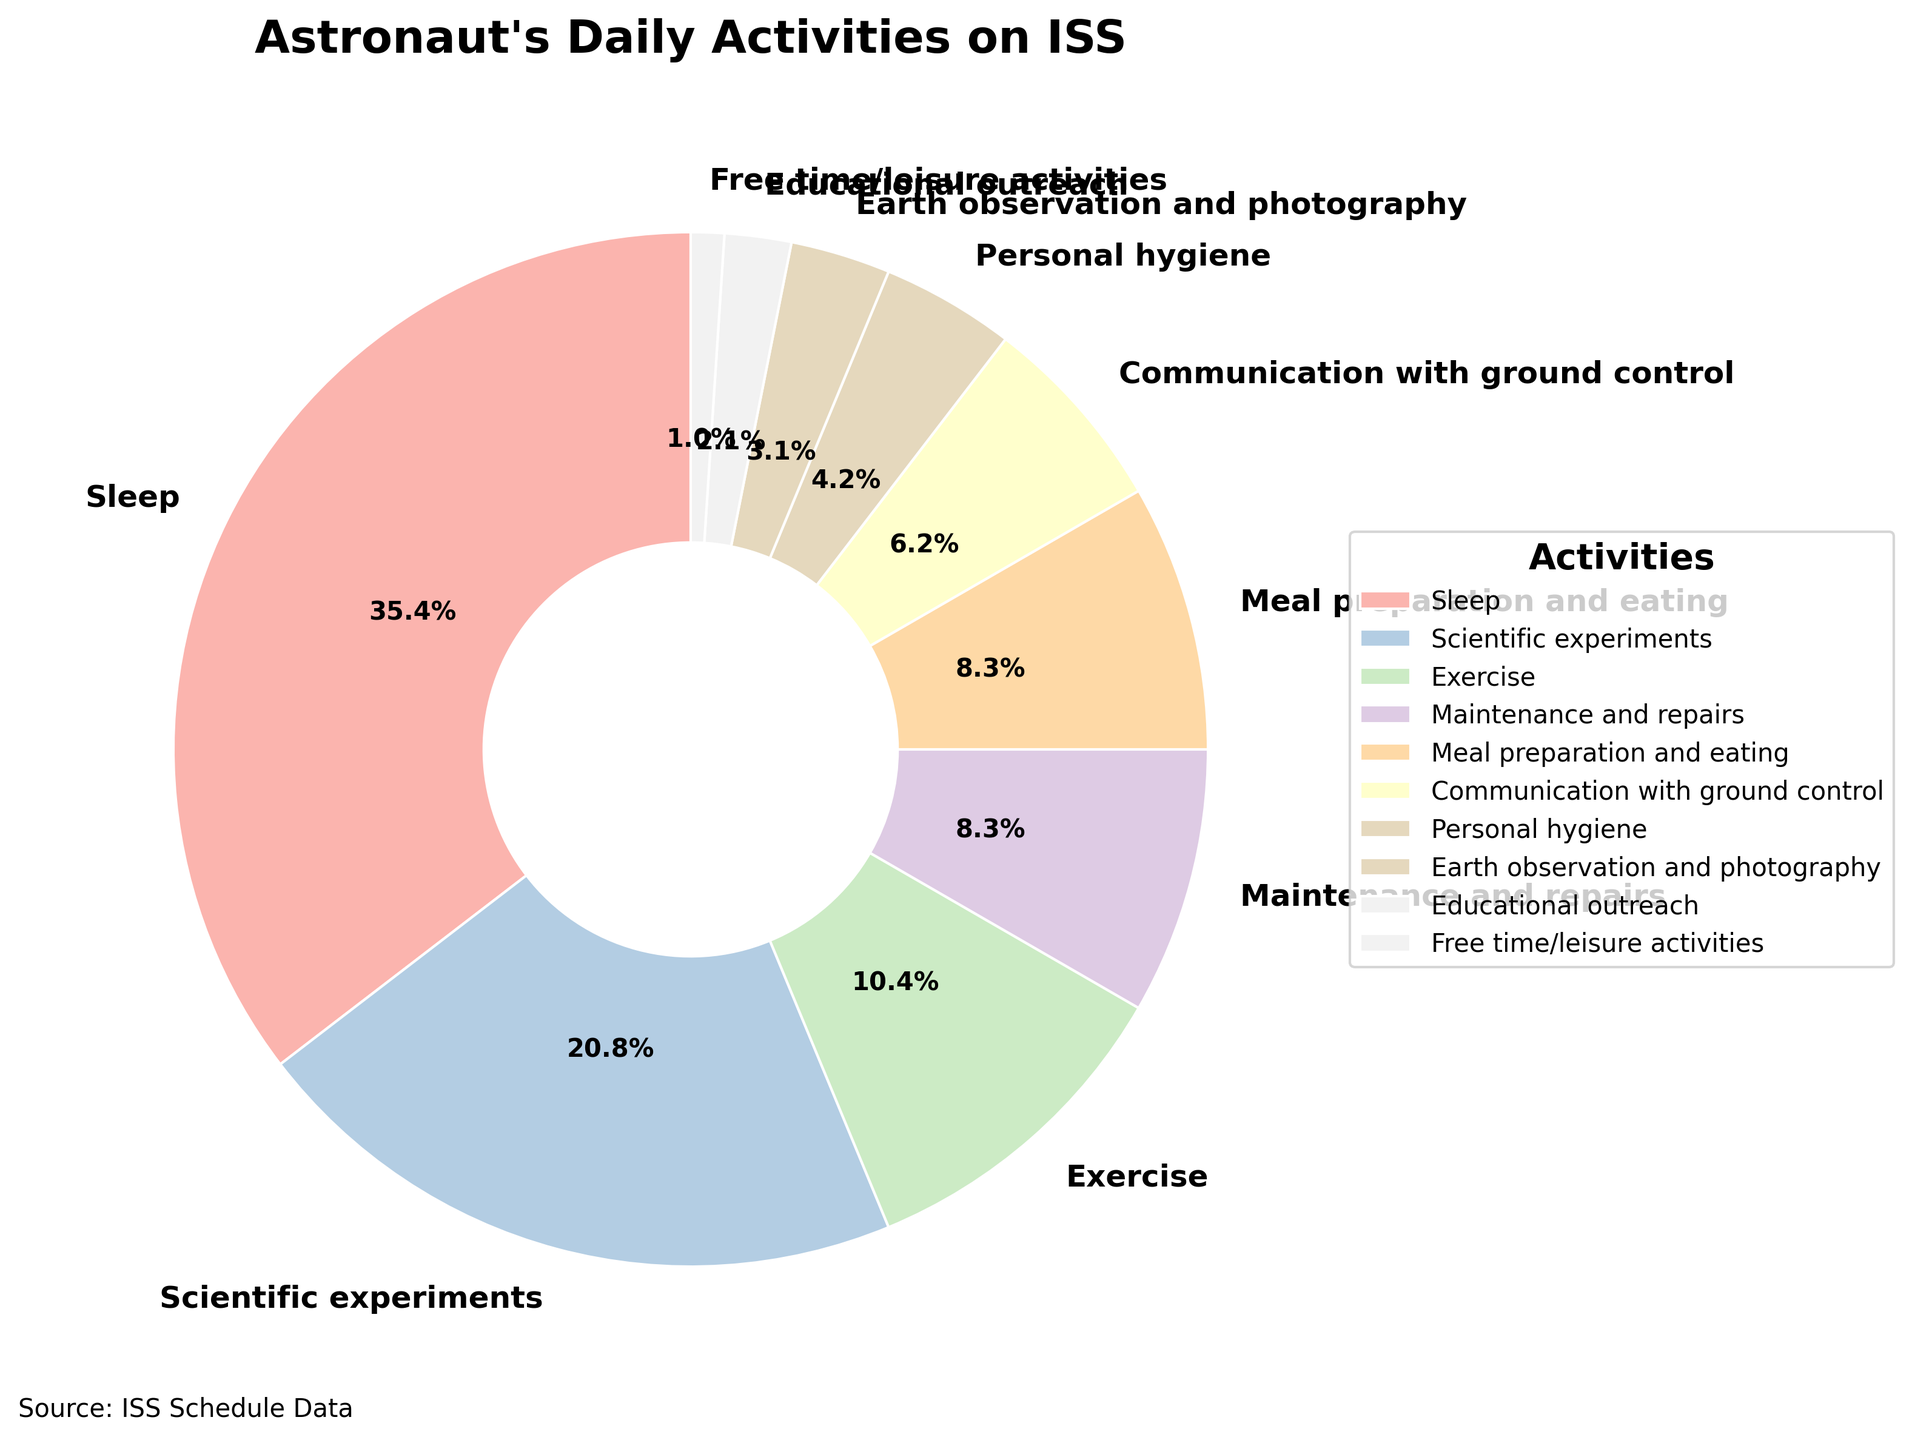Which activity occupies the most time in the astronaut's day? By looking at the chart, we can see that the largest slice of the pie is labeled "Sleep" which accounts for 8.5 hours.
Answer: Sleep What percentage of the astronaut's day is spent on scientific experiments? By referring to the chart, we can see that the segment for "Scientific experiments" has a label indicating it occupies 20.8% of the total time.
Answer: 20.8% Which activity takes more time: exercise or educational outreach? By comparing the two segments of the chart, "Exercise" occupies 2.5 hours while "Educational outreach" occupies 0.5 hours. Therefore, exercise takes more time.
Answer: Exercise How much more time is spent on communication with ground control than on personal hygiene? From the chart, "Communication with ground control" takes 1.5 hours and "Personal hygiene" takes 1 hour. The difference is 1.5 - 1 = 0.5 hours.
Answer: 0.5 hours What is the total amount of time spent on meal preparation and eating, Earth observation and photography, and free time/leisure activities? The chart shows 2 hours for meal preparation and eating, 0.75 hours for Earth observation and photography, and 0.25 hours for free time/leisure activities. Summing these, 2 + 0.75 + 0.25 = 3 hours.
Answer: 3 hours Is the time spent on maintenance and repairs greater than the time spent on communication with ground control and personal hygiene combined? "Maintenance and repairs" takes 2 hours. "Communication with ground control" and "Personal hygiene" combined is 1.5 + 1 = 2.5 hours. Since 2 is less than 2.5, the time spent on maintenance and repairs is not greater.
Answer: No What fraction of the astronaut's day is dedicated to personal hygiene? The pie chart gives the hours spent on personal hygiene as 1 hour out of the 24-hour day. Hence, the fraction is 1/24.
Answer: 1/24 What is the combined percentage of time spent on exercise, meal preparation and eating, and maintenance and repairs? "Exercise" is 10.4%, "Meal preparation and eating" is 8.3%, and "Maintenance and repairs" is 8.3%. Adding these gives 10.4 + 8.3 + 8.3 = 27%.
Answer: 27% Among personal hygiene, Earth observation and photography, and free time/leisure, which one takes up the least of an astronaut's daily time? By looking at the different slices, "Free time/leisure activities" takes 0.25 hours which is the smallest value among the given categories.
Answer: Free time/leisure activities 